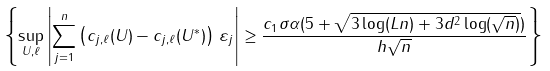<formula> <loc_0><loc_0><loc_500><loc_500>\left \{ \sup _ { U , \ell } \left | \sum _ { j = 1 } ^ { n } \left ( c _ { j , \ell } ( U ) - c _ { j , \ell } ( U ^ { * } ) \right ) \, \varepsilon _ { j } \right | \geq \frac { c _ { 1 } \sigma \alpha ( 5 + \sqrt { 3 \log ( L n ) + 3 d ^ { 2 } \log ( \sqrt { n } ) } ) } { h \sqrt { n } } \right \}</formula> 